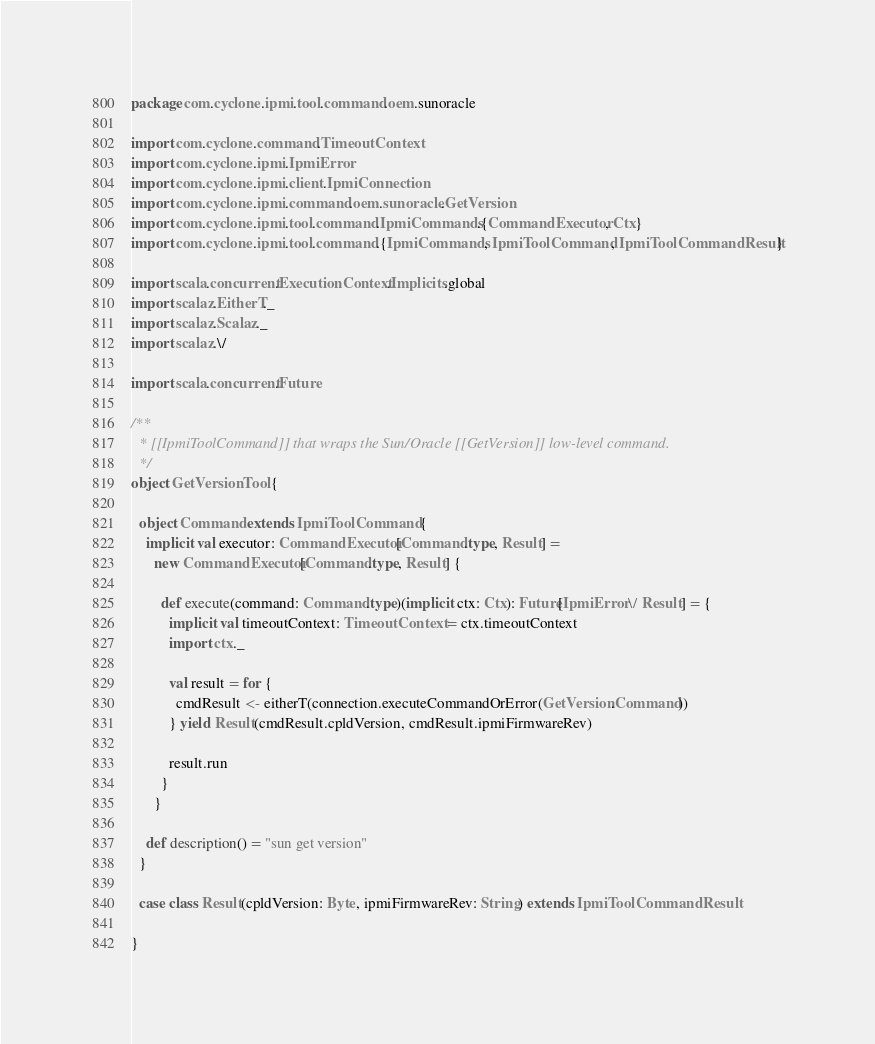Convert code to text. <code><loc_0><loc_0><loc_500><loc_500><_Scala_>package com.cyclone.ipmi.tool.command.oem.sunoracle

import com.cyclone.command.TimeoutContext
import com.cyclone.ipmi.IpmiError
import com.cyclone.ipmi.client.IpmiConnection
import com.cyclone.ipmi.command.oem.sunoracle.GetVersion
import com.cyclone.ipmi.tool.command.IpmiCommands.{CommandExecutor, Ctx}
import com.cyclone.ipmi.tool.command.{IpmiCommands, IpmiToolCommand, IpmiToolCommandResult}

import scala.concurrent.ExecutionContext.Implicits.global
import scalaz.EitherT._
import scalaz.Scalaz._
import scalaz.\/

import scala.concurrent.Future

/**
  * [[IpmiToolCommand]] that wraps the Sun/Oracle [[GetVersion]] low-level command.
  */
object GetVersionTool {

  object Command extends IpmiToolCommand {
    implicit val executor: CommandExecutor[Command.type, Result] =
      new CommandExecutor[Command.type, Result] {

        def execute(command: Command.type)(implicit ctx: Ctx): Future[IpmiError \/ Result] = {
          implicit val timeoutContext: TimeoutContext = ctx.timeoutContext
          import ctx._

          val result = for {
            cmdResult <- eitherT(connection.executeCommandOrError(GetVersion.Command))
          } yield Result(cmdResult.cpldVersion, cmdResult.ipmiFirmwareRev)

          result.run
        }
      }

    def description() = "sun get version"
  }

  case class Result(cpldVersion: Byte, ipmiFirmwareRev: String) extends IpmiToolCommandResult

}
</code> 